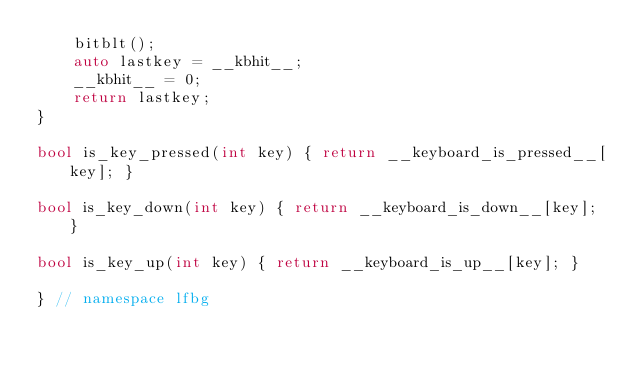<code> <loc_0><loc_0><loc_500><loc_500><_C++_>    bitblt();
    auto lastkey = __kbhit__;
    __kbhit__ = 0;
    return lastkey;
}

bool is_key_pressed(int key) { return __keyboard_is_pressed__[key]; }

bool is_key_down(int key) { return __keyboard_is_down__[key]; }

bool is_key_up(int key) { return __keyboard_is_up__[key]; }

} // namespace lfbg</code> 